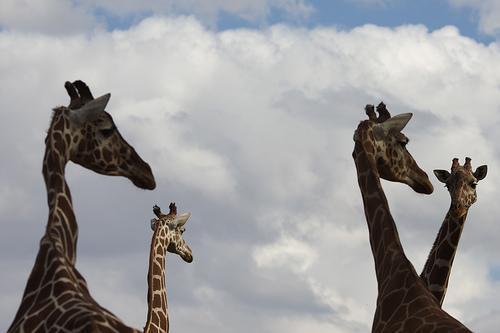How many giraffes are there?
Give a very brief answer. 4. How many giraffes are in the photo?
Give a very brief answer. 4. How many people are sitting at the table in this picture?
Give a very brief answer. 0. 